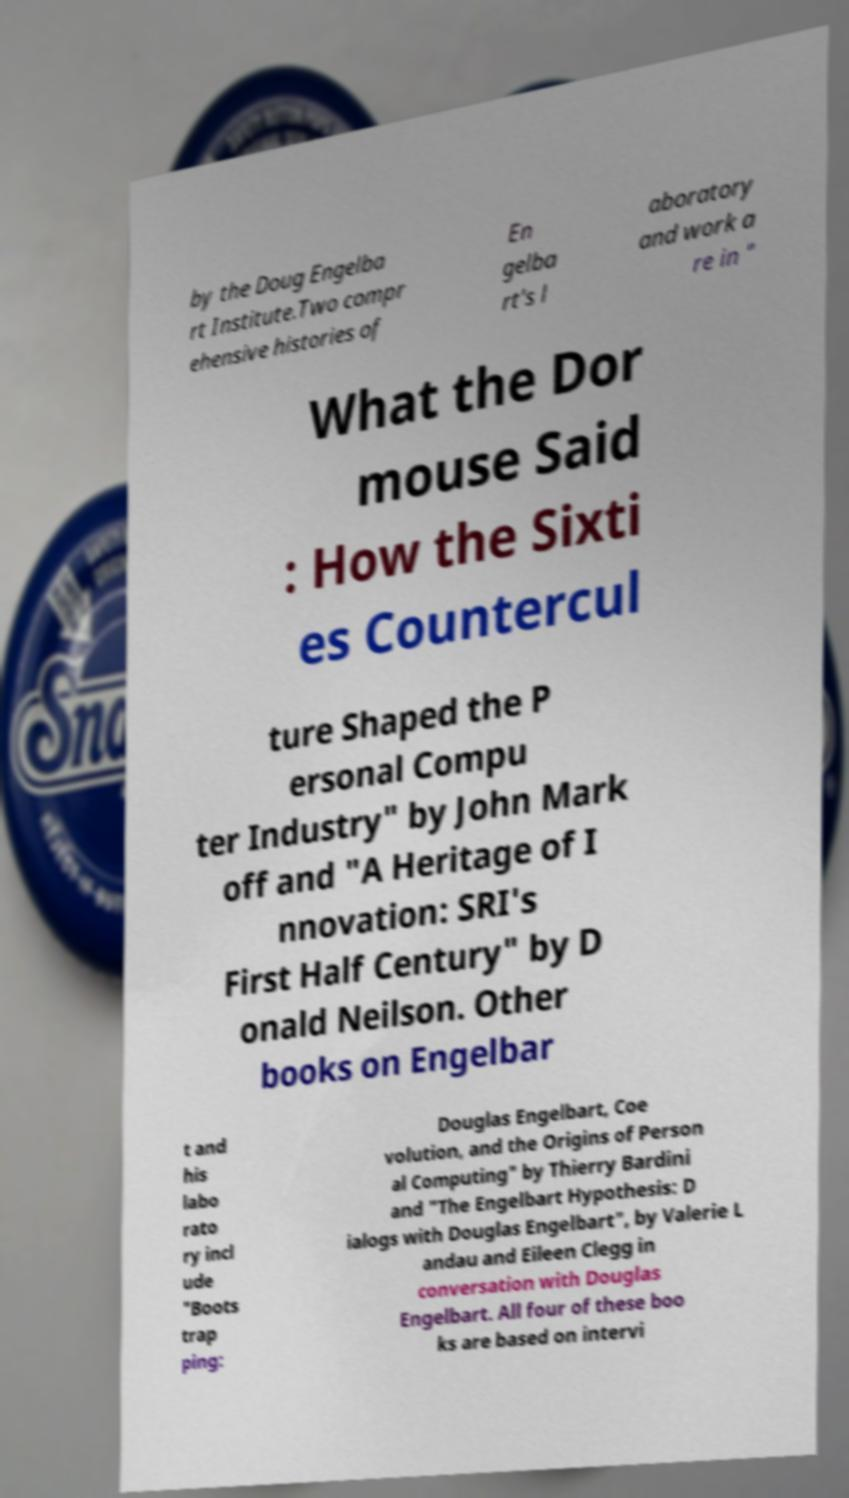There's text embedded in this image that I need extracted. Can you transcribe it verbatim? by the Doug Engelba rt Institute.Two compr ehensive histories of En gelba rt's l aboratory and work a re in " What the Dor mouse Said : How the Sixti es Countercul ture Shaped the P ersonal Compu ter Industry" by John Mark off and "A Heritage of I nnovation: SRI's First Half Century" by D onald Neilson. Other books on Engelbar t and his labo rato ry incl ude "Boots trap ping: Douglas Engelbart, Coe volution, and the Origins of Person al Computing" by Thierry Bardini and "The Engelbart Hypothesis: D ialogs with Douglas Engelbart", by Valerie L andau and Eileen Clegg in conversation with Douglas Engelbart. All four of these boo ks are based on intervi 